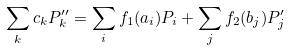Convert formula to latex. <formula><loc_0><loc_0><loc_500><loc_500>\sum _ { k } c _ { k } P _ { k } ^ { \prime \prime } = \sum _ { i } f _ { 1 } ( a _ { i } ) P _ { i } + \sum _ { j } f _ { 2 } ( b _ { j } ) P _ { j } ^ { \prime }</formula> 